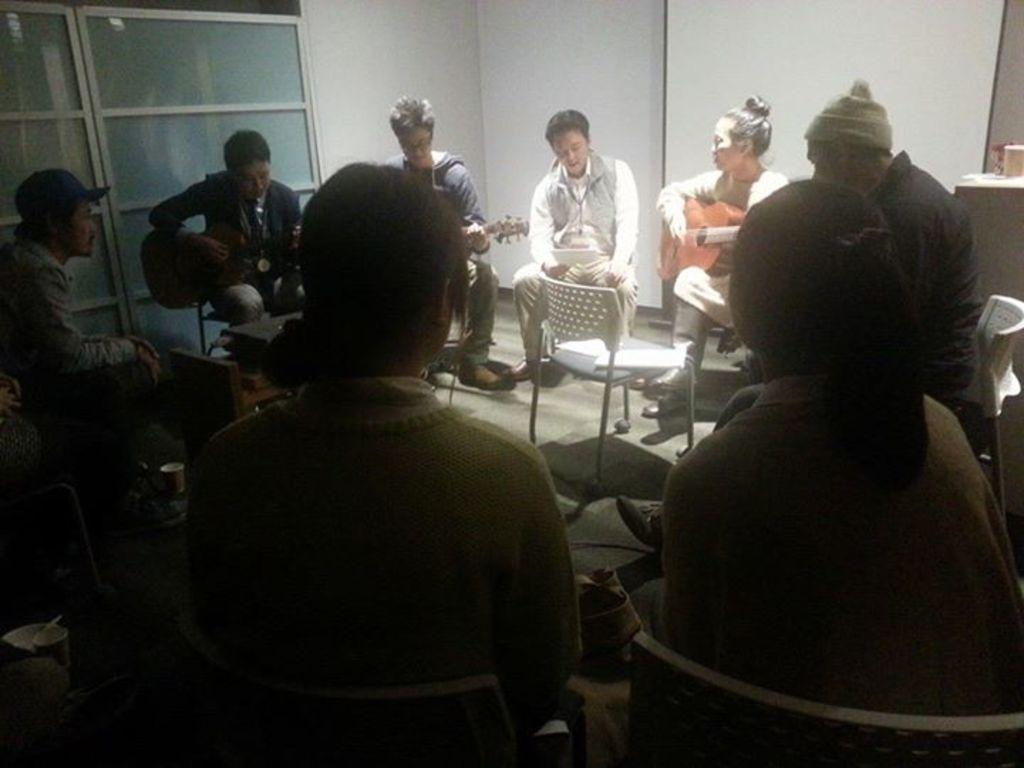What is happening in the image? There is a group of people in the image. What are the people doing in the image? The people are seated on chairs, and some of them are playing guitars. What type of grape is being used as a pick for the guitar in the image? There is no grape being used as a pick for the guitar in the image. Is there a soap dispenser visible in the image? There is no soap dispenser present in the image. 